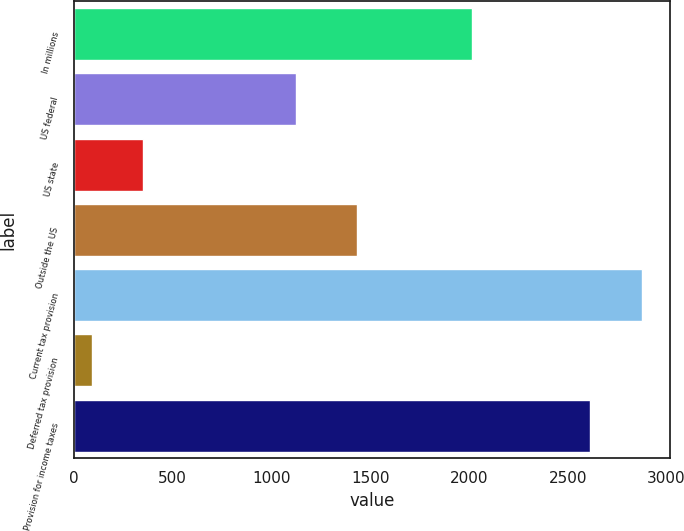<chart> <loc_0><loc_0><loc_500><loc_500><bar_chart><fcel>In millions<fcel>US federal<fcel>US state<fcel>Outside the US<fcel>Current tax provision<fcel>Deferred tax provision<fcel>Provision for income taxes<nl><fcel>2014<fcel>1124.8<fcel>352.12<fcel>1431.7<fcel>2875.62<fcel>90.7<fcel>2614.2<nl></chart> 